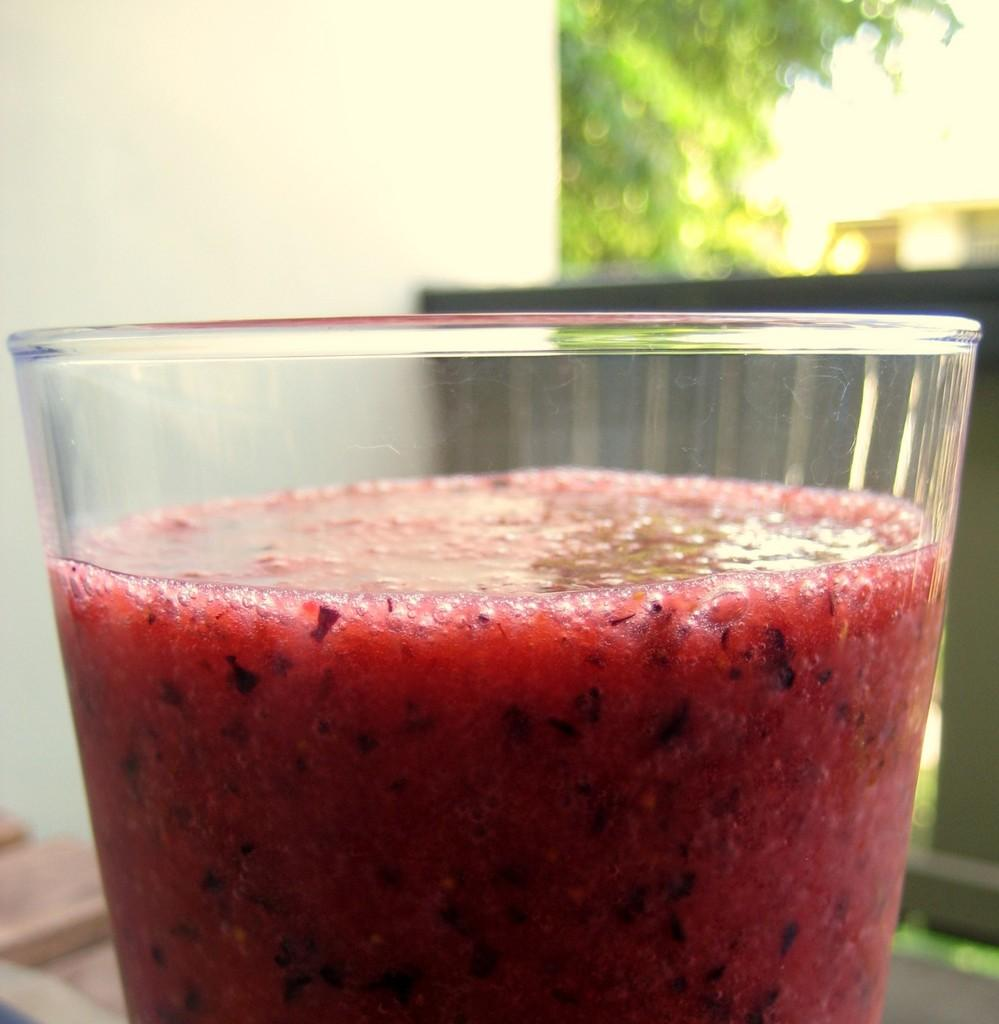What type of photography is used in the image? The image is a macro photography. What is the main subject of the macro photography? The subject of the macro photography is a liquid in a glass. What color is the liquid in the glass? The liquid is red in color. How many toes can be seen in the image? There are no toes visible in the image, as it features a macro photography of a red liquid in a glass. 